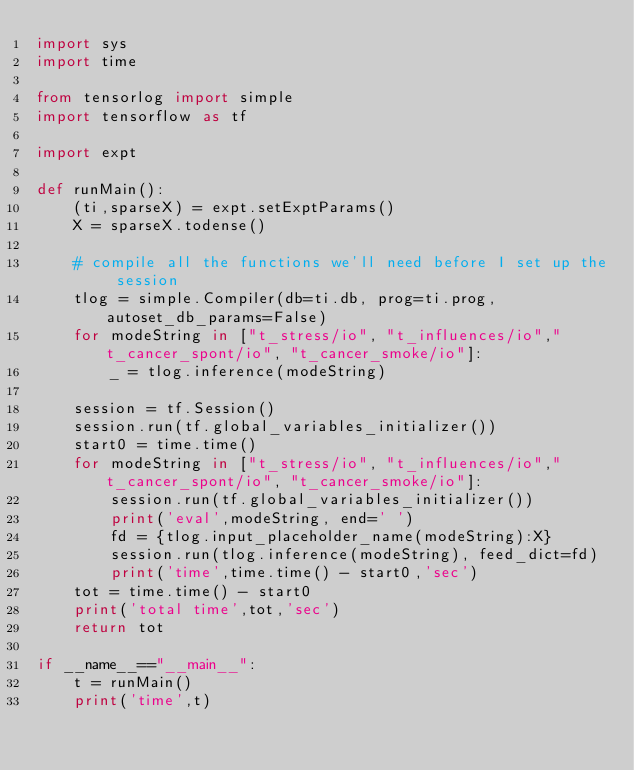Convert code to text. <code><loc_0><loc_0><loc_500><loc_500><_Python_>import sys
import time

from tensorlog import simple
import tensorflow as tf

import expt

def runMain():
    (ti,sparseX) = expt.setExptParams()
    X = sparseX.todense()

    # compile all the functions we'll need before I set up the session
    tlog = simple.Compiler(db=ti.db, prog=ti.prog, autoset_db_params=False)
    for modeString in ["t_stress/io", "t_influences/io","t_cancer_spont/io", "t_cancer_smoke/io"]:
        _ = tlog.inference(modeString)

    session = tf.Session()
    session.run(tf.global_variables_initializer())
    start0 = time.time()
    for modeString in ["t_stress/io", "t_influences/io","t_cancer_spont/io", "t_cancer_smoke/io"]:
        session.run(tf.global_variables_initializer())
        print('eval',modeString, end=' ')
        fd = {tlog.input_placeholder_name(modeString):X}
        session.run(tlog.inference(modeString), feed_dict=fd)
        print('time',time.time() - start0,'sec')
    tot = time.time() - start0
    print('total time',tot,'sec')
    return tot

if __name__=="__main__":
    t = runMain()
    print('time',t)
</code> 